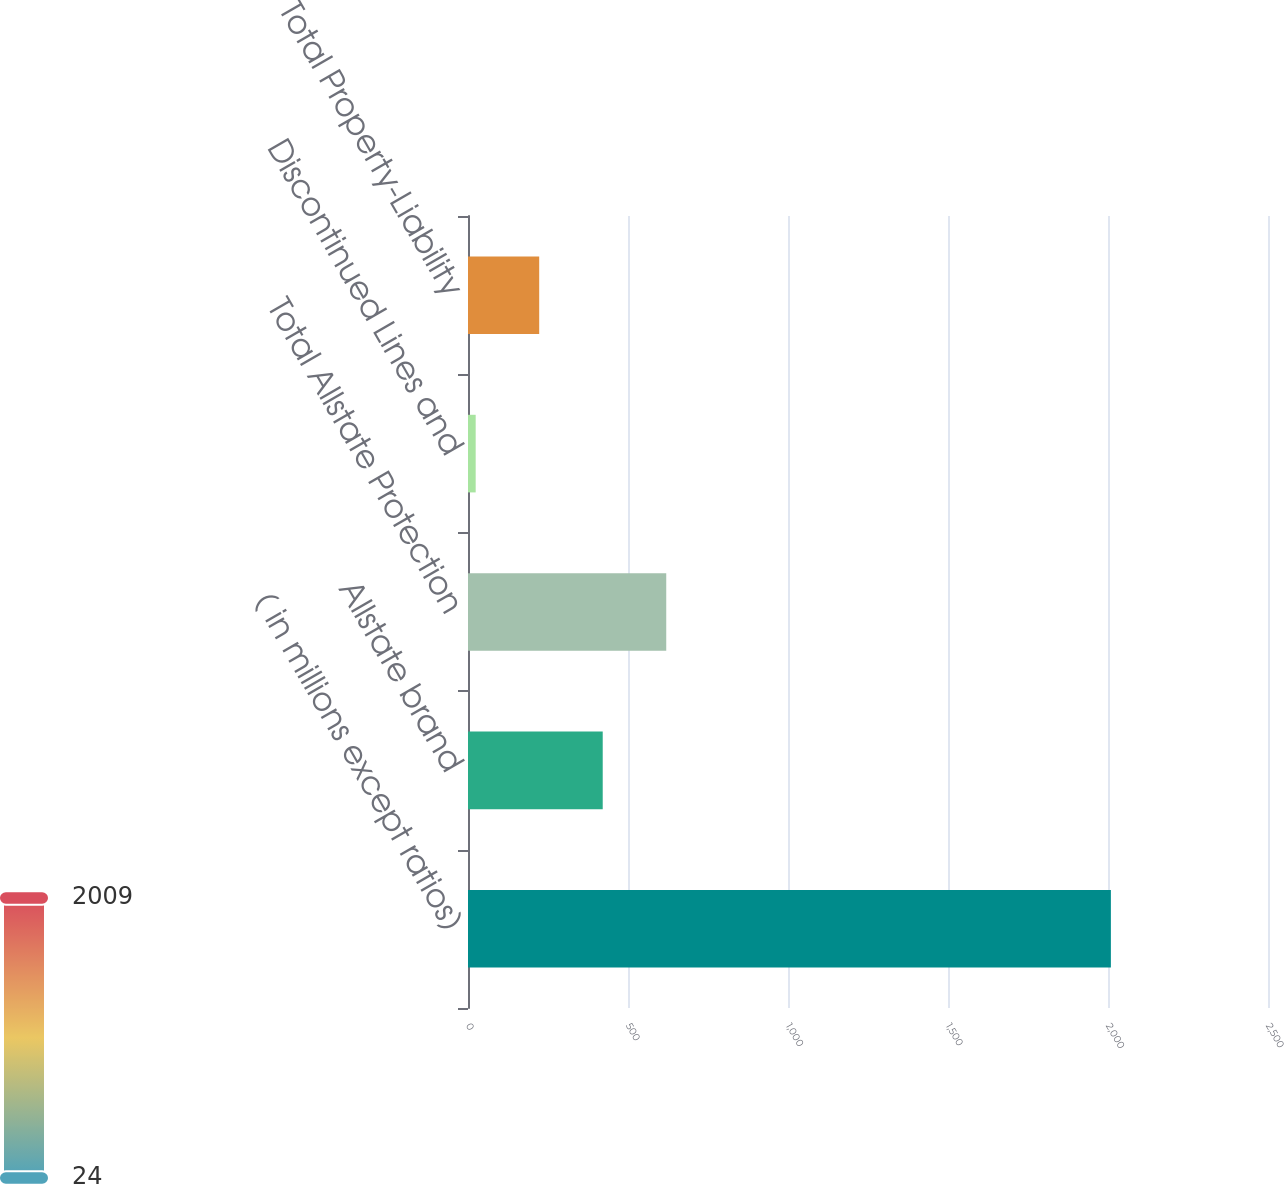<chart> <loc_0><loc_0><loc_500><loc_500><bar_chart><fcel>( in millions except ratios)<fcel>Allstate brand<fcel>Total Allstate Protection<fcel>Discontinued Lines and<fcel>Total Property-Liability<nl><fcel>2009<fcel>421<fcel>619.5<fcel>24<fcel>222.5<nl></chart> 